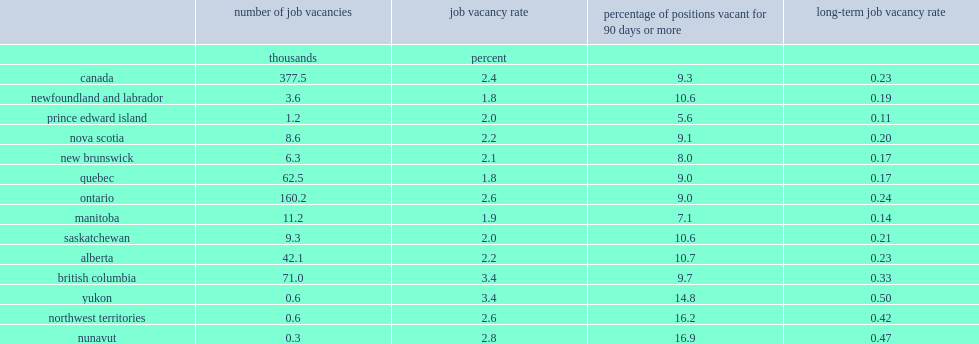Which province in canada had the highest rate of long-term job vacancy? British columbia. What is the lowest long-term job vacancy rate? 0.11. List top 4 provinces or territories that could find most long-term job vacancies. Ontario british columbia quebec alberta. 